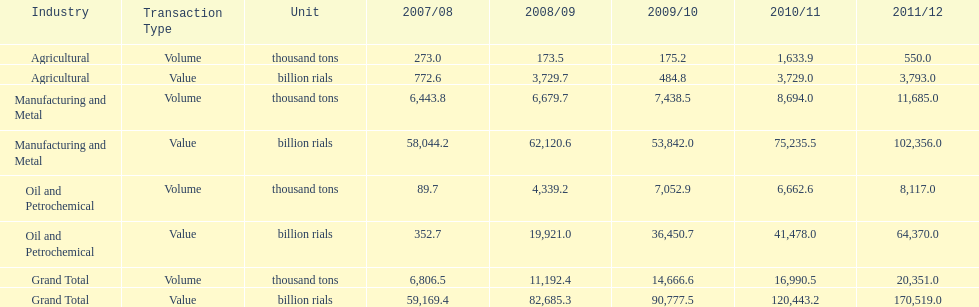How many consecutive year did the grand total value grow in iran? 4. 